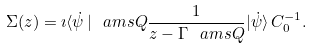Convert formula to latex. <formula><loc_0><loc_0><loc_500><loc_500>\Sigma ( z ) = \imath \langle \dot { \psi } \, | \ a m s { Q } \frac { 1 } { z - \Gamma \ a m s { Q } } | \dot { \psi } \rangle \, C ^ { - 1 } _ { 0 } .</formula> 